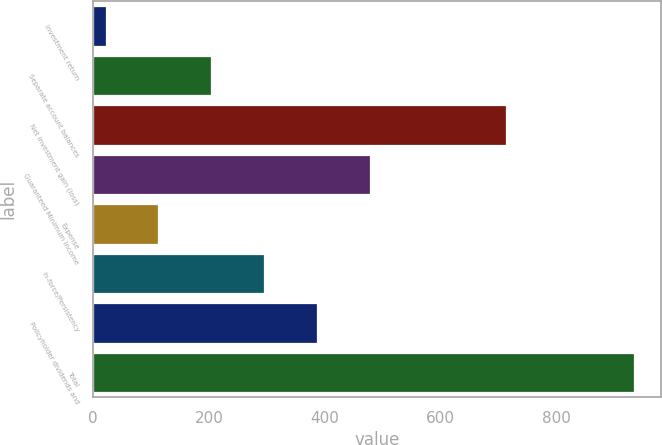Convert chart. <chart><loc_0><loc_0><loc_500><loc_500><bar_chart><fcel>Investment return<fcel>Separate account balances<fcel>Net investment gain (loss)<fcel>Guaranteed Minimum Income<fcel>Expense<fcel>In-force/Persistency<fcel>Policyholder dividends and<fcel>Total<nl><fcel>22<fcel>204.2<fcel>712<fcel>477.5<fcel>113.1<fcel>295.3<fcel>386.4<fcel>933<nl></chart> 